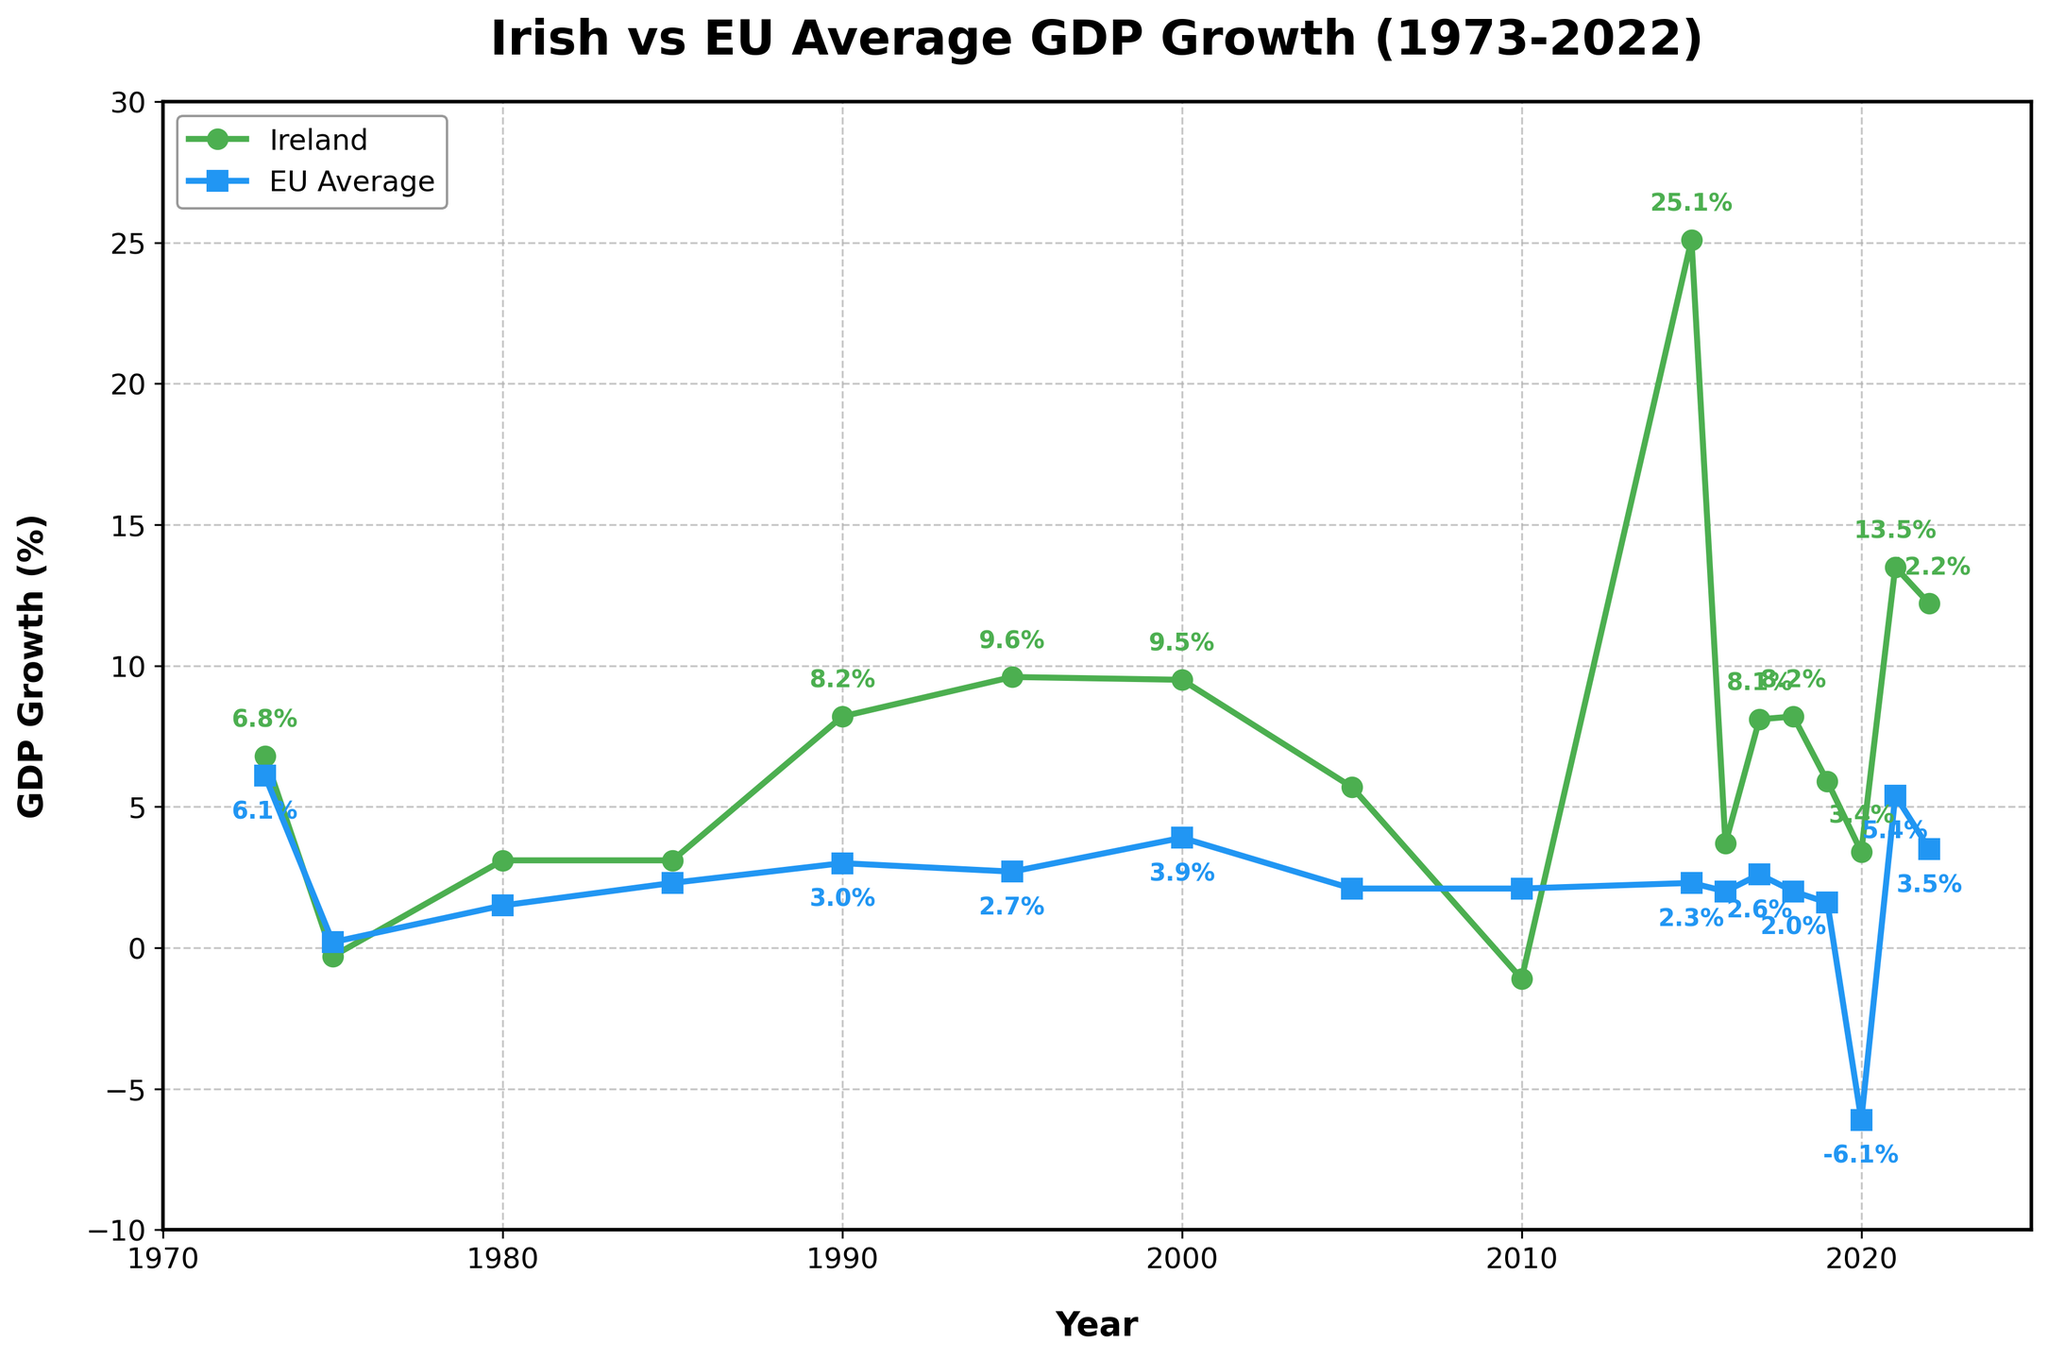What was the GDP growth for Ireland and the EU in 1973? To find the GDP growth for both regions in 1973, simply locate the appropriate values on the chart for the year 1973. The figure indicates that in 1973, Ireland had a GDP growth rate of 6.8%, and the EU average was 6.1%.
Answer: Ireland: 6.8%, EU: 6.1% How did Ireland's GDP growth rate compare to the EU average in 2010? Look at the data points for both Ireland and the EU in 2010. Ireland's GDP growth was -1.1%, while the EU average was 2.1%. To compare, Ireland's rate was 3.2% lower than the EU's.
Answer: Ireland was 3.2% lower Which year shows the highest GDP growth rate for Ireland, and what was the rate? Identify the highest data point on the Ireland GDP growth line. The highest GDP growth rate for Ireland is found in 2015, with a growth rate of 25.1%.
Answer: 2015, 25.1% In which year was the difference between Ireland and the EU's GDP growth rate the greatest? What was the difference? Calculate the differences between Ireland's and the EU's GDP growth rates for each year, then identify the year with the maximum difference. In 2015, the difference was the greatest at 22.8% (Ireland 25.1% - EU 2.3%).
Answer: 2015, difference: 22.8% How many times did Ireland's GDP growth rate fall below zero? Count the number of times the GDP growth line for Ireland dips below the zero mark. Ireland's GDP growth rate fell below zero twice, in 1975 and 2010.
Answer: Twice What was the common trend in GDP growth rates for both Ireland and the EU in 2020? Observe both lines for the year 2020. Ireland showed positive growth at 3.4%, while the EU showed a significant decline at -6.1%. The common trend is that their growth rates diverged significantly.
Answer: Diverged significantly Between 1973 and 2022, in how many years did Ireland have a higher GDP growth rate compared to the EU average? Compare the GDP growth rates of Ireland and the EU for each year. Ireland had a higher GDP growth rate in 10 out of the 16 years presented.
Answer: 10 years If we average the GDP growth rates of Ireland from 2000 to 2005, what would the value be? Sum the GDP growth rates of Ireland for the years 2000, 2005, 2010, divide by the number of years (3). The sum is 9.5% (2000) + 5.7% (2005) - 1.1% (2010) = 14.1%. The average is 14.1%/3 = 4.7%.
Answer: 4.7% 